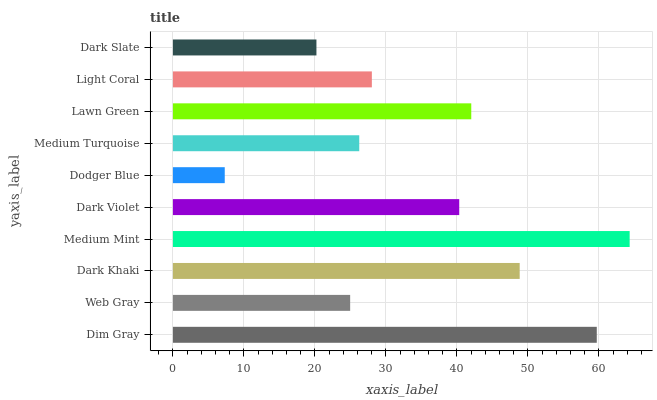Is Dodger Blue the minimum?
Answer yes or no. Yes. Is Medium Mint the maximum?
Answer yes or no. Yes. Is Web Gray the minimum?
Answer yes or no. No. Is Web Gray the maximum?
Answer yes or no. No. Is Dim Gray greater than Web Gray?
Answer yes or no. Yes. Is Web Gray less than Dim Gray?
Answer yes or no. Yes. Is Web Gray greater than Dim Gray?
Answer yes or no. No. Is Dim Gray less than Web Gray?
Answer yes or no. No. Is Dark Violet the high median?
Answer yes or no. Yes. Is Light Coral the low median?
Answer yes or no. Yes. Is Web Gray the high median?
Answer yes or no. No. Is Dim Gray the low median?
Answer yes or no. No. 